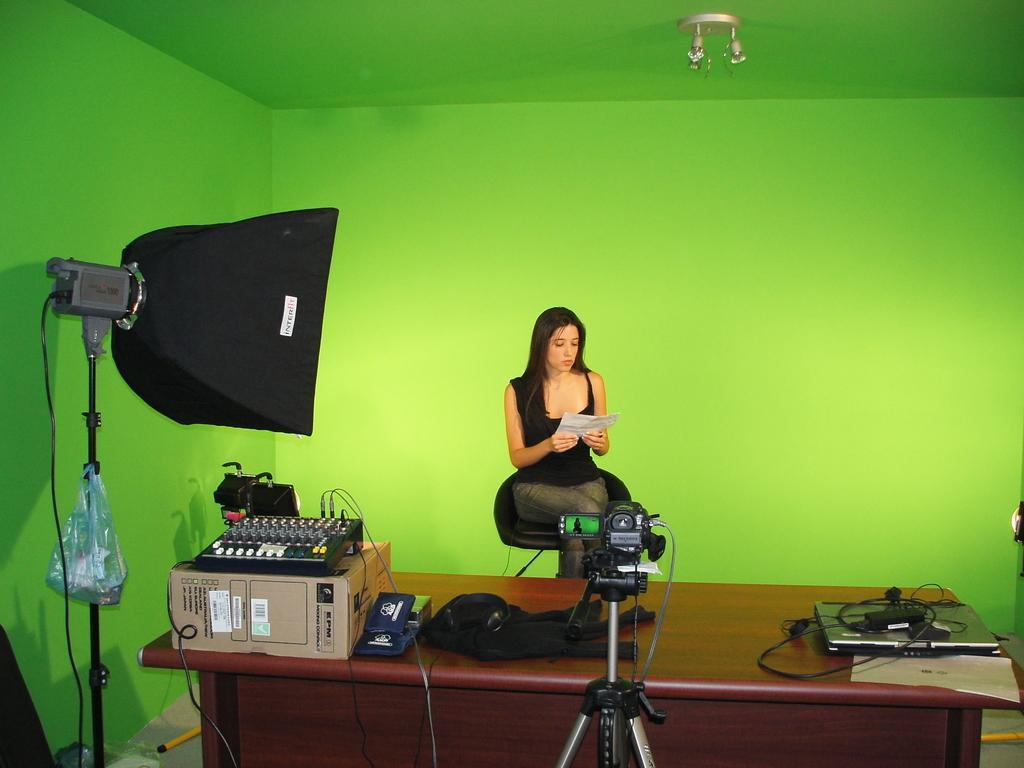Please provide a concise description of this image. In the middle of the image there is a stand with a video camera. Behind that there is a table. On the table there is a laptop with charger, cardboard box with an object and also there are some other things on it. Beside the table there is a stand with black object. Behind the table there is a lady sitting on the chair and holding a paper in the hand. At the top of the image there are lights. 